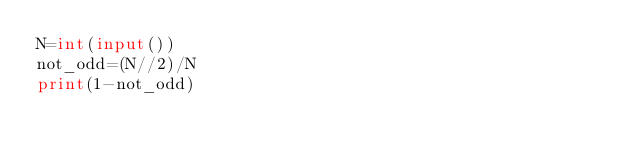Convert code to text. <code><loc_0><loc_0><loc_500><loc_500><_Python_>N=int(input())
not_odd=(N//2)/N
print(1-not_odd)</code> 